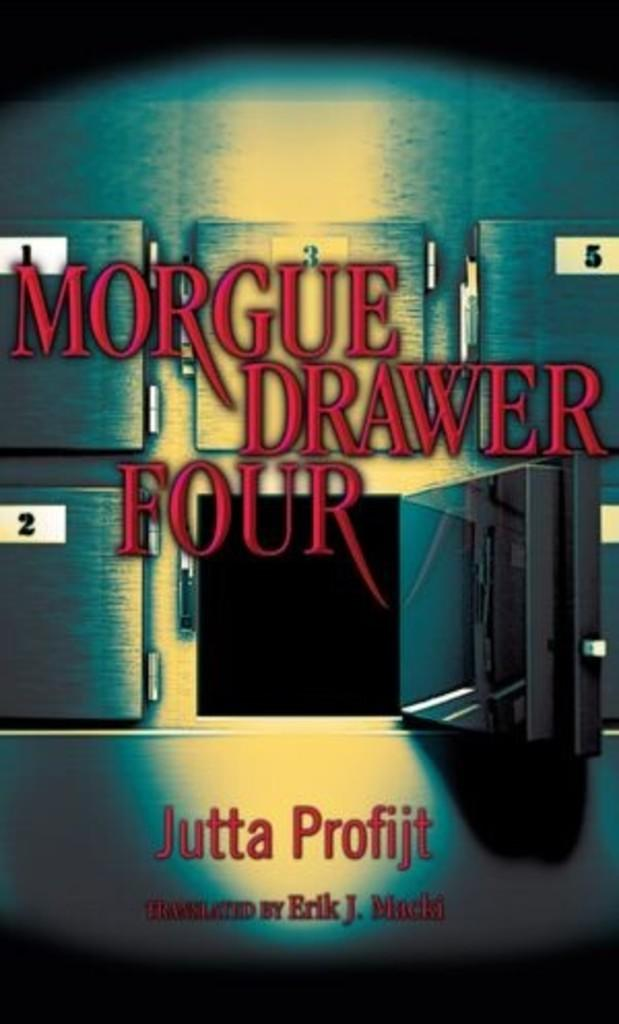<image>
Relay a brief, clear account of the picture shown. A cover of a book written by Jutta Profijt. 